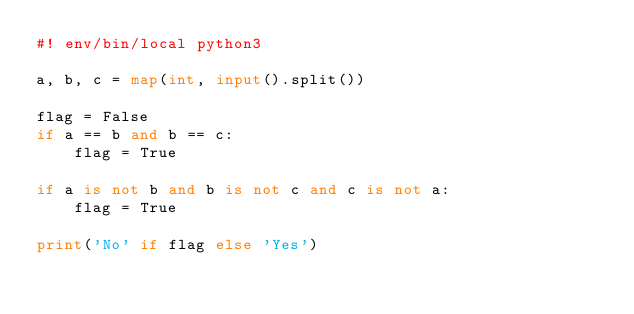<code> <loc_0><loc_0><loc_500><loc_500><_Python_>#! env/bin/local python3

a, b, c = map(int, input().split())

flag = False
if a == b and b == c:
    flag = True

if a is not b and b is not c and c is not a:
    flag = True

print('No' if flag else 'Yes')</code> 